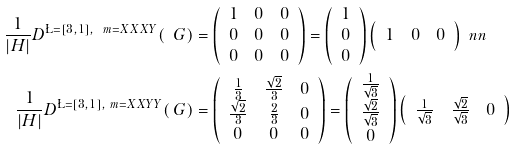<formula> <loc_0><loc_0><loc_500><loc_500>\frac { 1 } { | H | } D ^ { \L = [ 3 , 1 ] , \ m = X X X Y } ( \ G ) & = \left ( \begin{array} { c c c } 1 & 0 & 0 \\ 0 & 0 & 0 \\ 0 & 0 & 0 \end{array} \right ) = \left ( \begin{array} { c } 1 \\ 0 \\ 0 \end{array} \right ) \left ( \begin{array} { c c c } 1 & 0 & 0 \end{array} \right ) \ n n \\ \frac { 1 } { | H | } D ^ { \L = [ 3 , 1 ] , \ m = X X Y Y } ( \ G ) & = \left ( \begin{array} { c c c } \frac { 1 } { 3 } & \frac { \sqrt { 2 } } { 3 } & 0 \\ \frac { \sqrt { 2 } } { 3 } & \frac { 2 } { 3 } & 0 \\ 0 & 0 & 0 \end{array} \right ) = \left ( \begin{array} { c } \frac { 1 } { \sqrt { 3 } } \\ \frac { \sqrt { 2 } } { \sqrt { 3 } } \\ 0 \end{array} \right ) \left ( \begin{array} { c c c } \frac { 1 } { \sqrt { 3 } } & \frac { \sqrt { 2 } } { \sqrt { 3 } } & 0 \end{array} \right )</formula> 